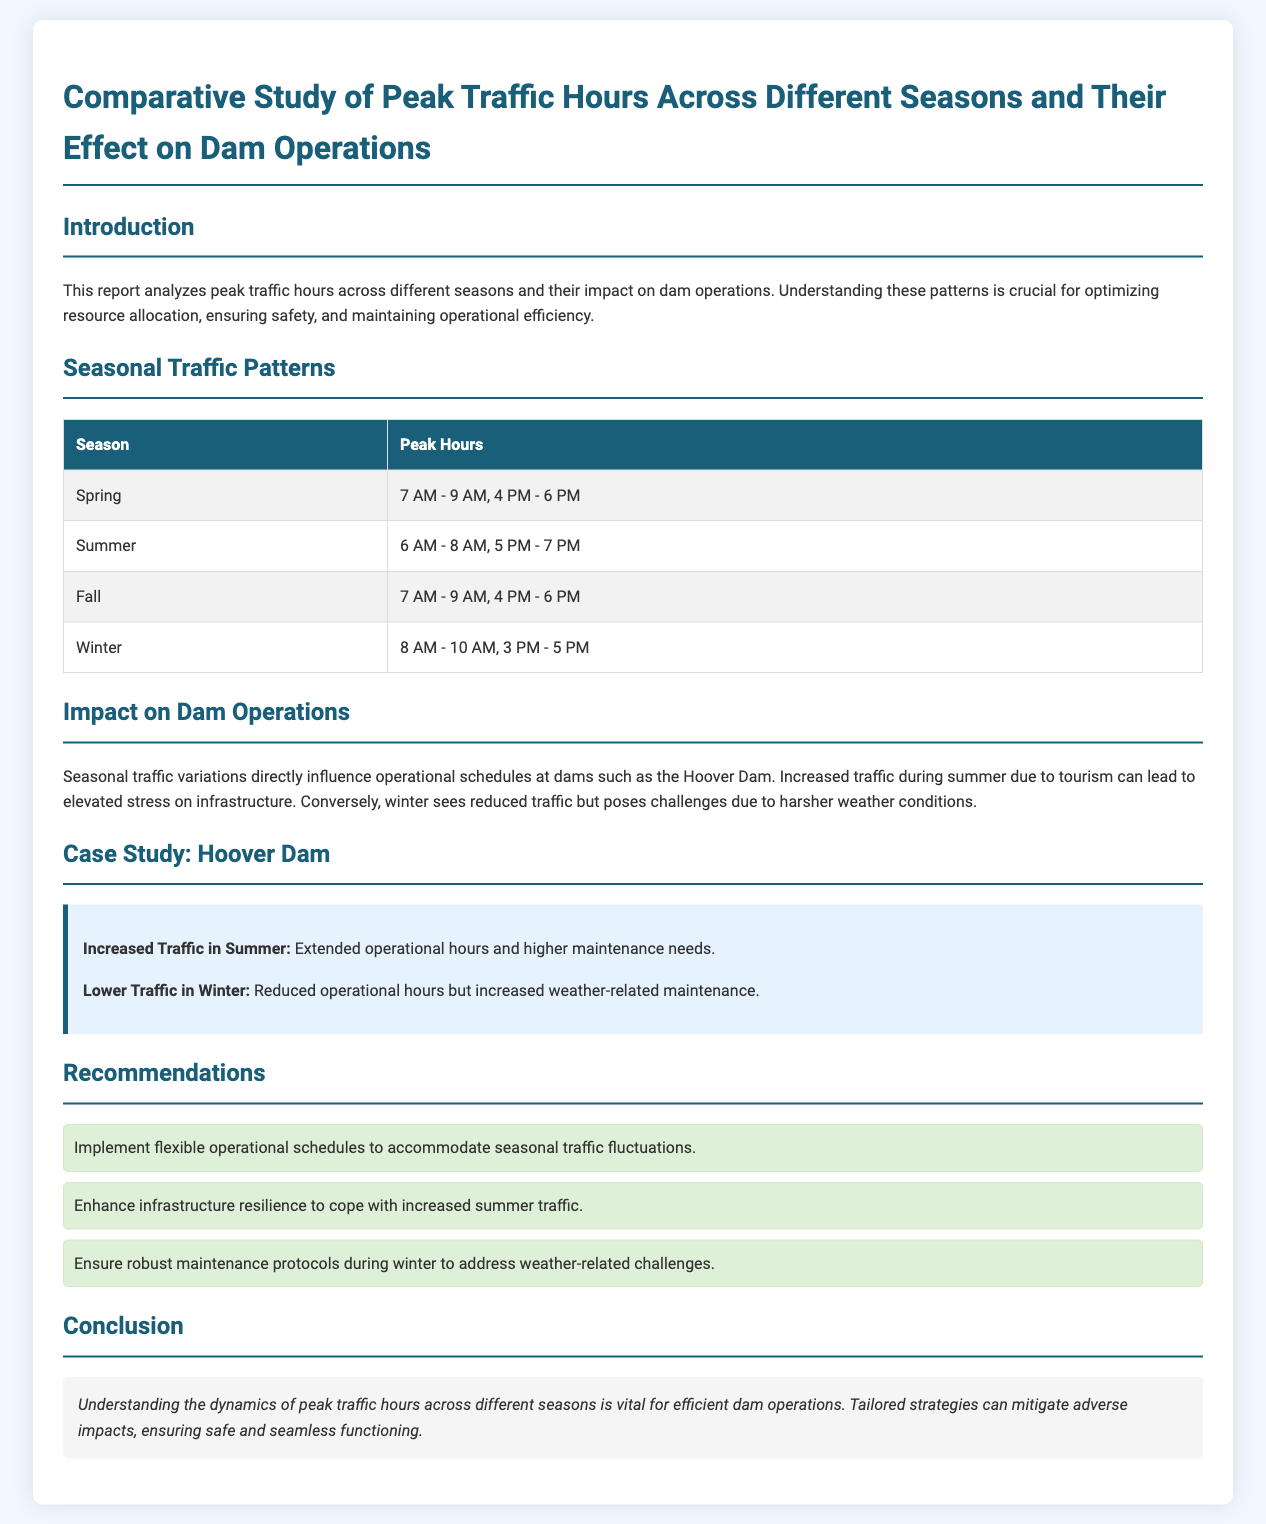What are the peak hours in spring? The document lists the peak hours for spring as 7 AM - 9 AM, 4 PM - 6 PM.
Answer: 7 AM - 9 AM, 4 PM - 6 PM What season has the earliest peak hours? The peak hours for summer start earliest at 6 AM.
Answer: Summer What challenges are posed by winter traffic? The document states that winter presents challenges due to harsher weather conditions.
Answer: Harsher weather What is a recommendation for summer traffic management? One of the recommendations is to enhance infrastructure resilience to cope with increased summer traffic.
Answer: Enhance infrastructure resilience Which case study is mentioned in the report? The document includes a case study on the Hoover Dam.
Answer: Hoover Dam What are the peak hours in winter? The document states that peak hours during winter are 8 AM - 10 AM, 3 PM - 5 PM.
Answer: 8 AM - 10 AM, 3 PM - 5 PM What is the overall impact of seasonal traffic patterns on dam operations? The report mentions that seasonal traffic variations influence operational schedules at dams.
Answer: Influence operational schedules What is the effect of increased traffic during summer? Increased traffic in summer leads to extended operational hours and higher maintenance needs.
Answer: Extended operational hours What is the tone of the conclusion? The conclusion emphasizes the importance of understanding traffic dynamics for efficient dam operations.
Answer: Importance of understanding traffic dynamics 